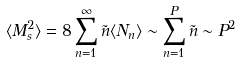<formula> <loc_0><loc_0><loc_500><loc_500>\langle M ^ { 2 } _ { s } \rangle = 8 \sum _ { n = 1 } ^ { \infty } \tilde { n } \langle N _ { n } \rangle \sim \sum _ { n = 1 } ^ { P } \tilde { n } \sim P ^ { 2 }</formula> 